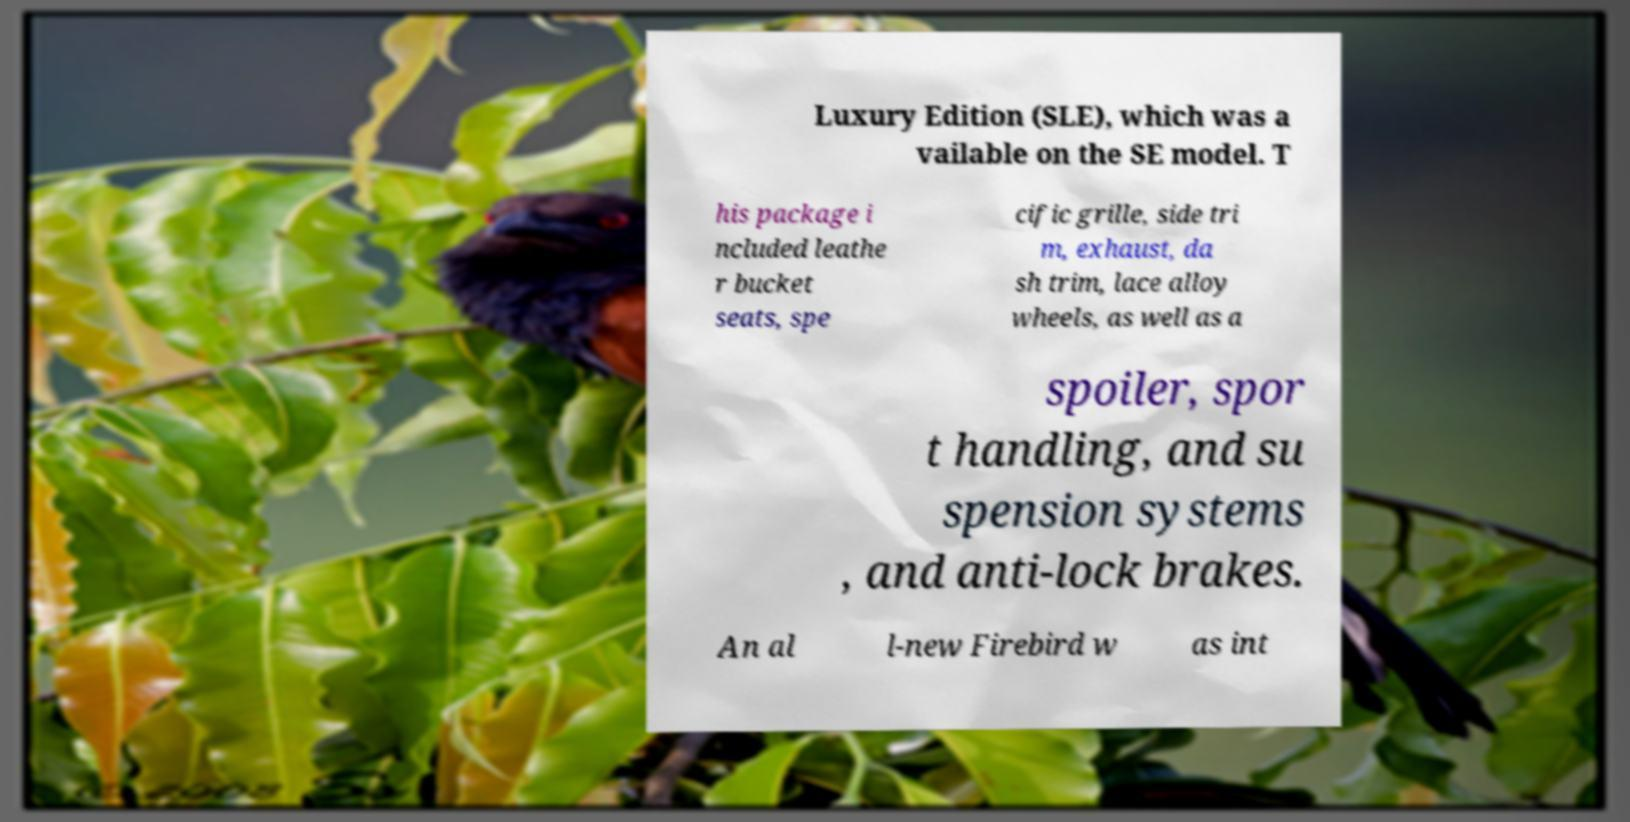Can you read and provide the text displayed in the image?This photo seems to have some interesting text. Can you extract and type it out for me? Luxury Edition (SLE), which was a vailable on the SE model. T his package i ncluded leathe r bucket seats, spe cific grille, side tri m, exhaust, da sh trim, lace alloy wheels, as well as a spoiler, spor t handling, and su spension systems , and anti-lock brakes. An al l-new Firebird w as int 